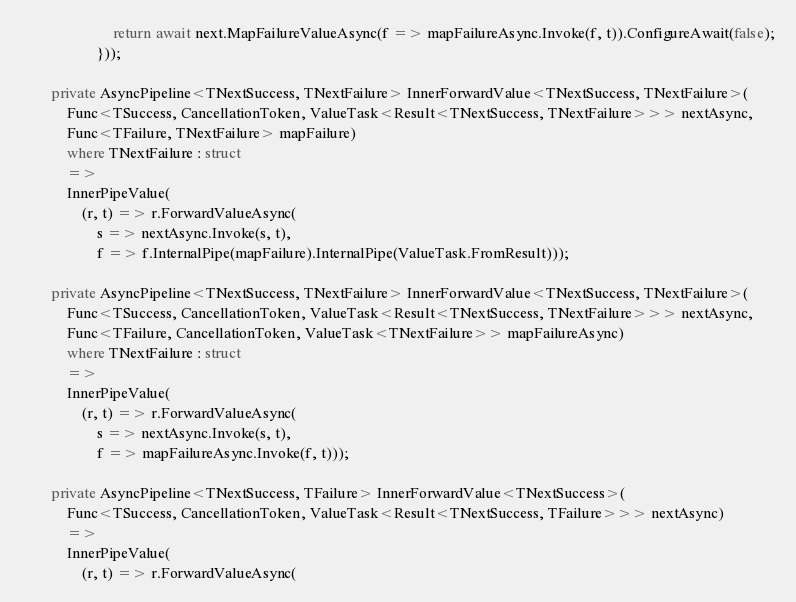<code> <loc_0><loc_0><loc_500><loc_500><_C#_>                        return await next.MapFailureValueAsync(f => mapFailureAsync.Invoke(f, t)).ConfigureAwait(false);
                    }));

        private AsyncPipeline<TNextSuccess, TNextFailure> InnerForwardValue<TNextSuccess, TNextFailure>(
            Func<TSuccess, CancellationToken, ValueTask<Result<TNextSuccess, TNextFailure>>> nextAsync,
            Func<TFailure, TNextFailure> mapFailure)
            where TNextFailure : struct
            =>
            InnerPipeValue(
                (r, t) => r.ForwardValueAsync(
                    s => nextAsync.Invoke(s, t),
                    f => f.InternalPipe(mapFailure).InternalPipe(ValueTask.FromResult)));

        private AsyncPipeline<TNextSuccess, TNextFailure> InnerForwardValue<TNextSuccess, TNextFailure>(
            Func<TSuccess, CancellationToken, ValueTask<Result<TNextSuccess, TNextFailure>>> nextAsync,
            Func<TFailure, CancellationToken, ValueTask<TNextFailure>> mapFailureAsync)
            where TNextFailure : struct
            =>
            InnerPipeValue(
                (r, t) => r.ForwardValueAsync(
                    s => nextAsync.Invoke(s, t),
                    f => mapFailureAsync.Invoke(f, t)));

        private AsyncPipeline<TNextSuccess, TFailure> InnerForwardValue<TNextSuccess>(
            Func<TSuccess, CancellationToken, ValueTask<Result<TNextSuccess, TFailure>>> nextAsync)
            =>
            InnerPipeValue(
                (r, t) => r.ForwardValueAsync(</code> 